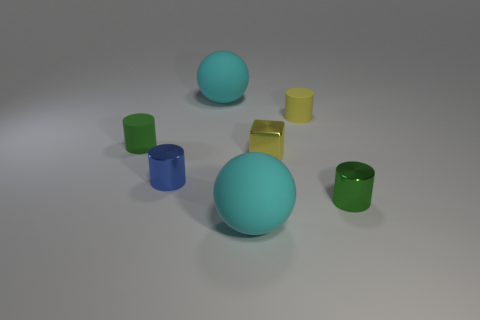Add 2 big objects. How many objects exist? 9 Subtract all blocks. How many objects are left? 6 Subtract all small cyan cubes. Subtract all large cyan spheres. How many objects are left? 5 Add 7 tiny green matte things. How many tiny green matte things are left? 8 Add 1 cubes. How many cubes exist? 2 Subtract 0 blue cubes. How many objects are left? 7 